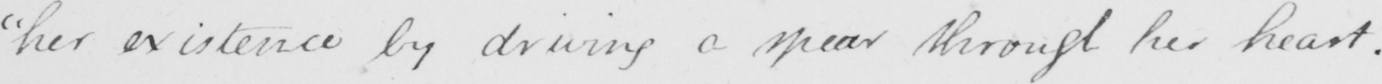Can you tell me what this handwritten text says? "her existence by driving a spear through her heart. 